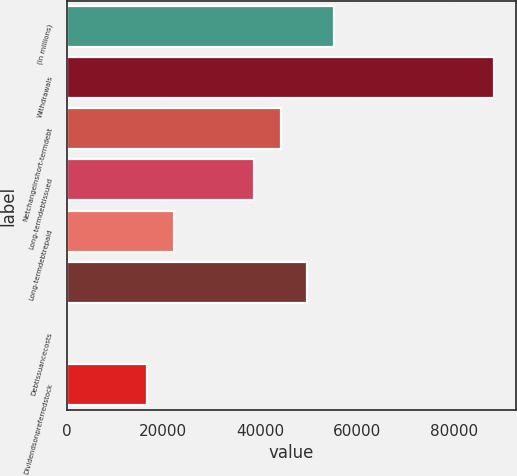Convert chart to OTSL. <chart><loc_0><loc_0><loc_500><loc_500><bar_chart><fcel>(In millions)<fcel>Withdrawals<fcel>Netchangeinshort-termdebt<fcel>Long-termdebtissued<fcel>Long-termdebtrepaid<fcel>Unnamed: 5<fcel>Debtissuancecosts<fcel>Dividendsonpreferredstock<nl><fcel>55256<fcel>88401.2<fcel>44207.6<fcel>38683.4<fcel>22110.8<fcel>49731.8<fcel>14<fcel>16586.6<nl></chart> 